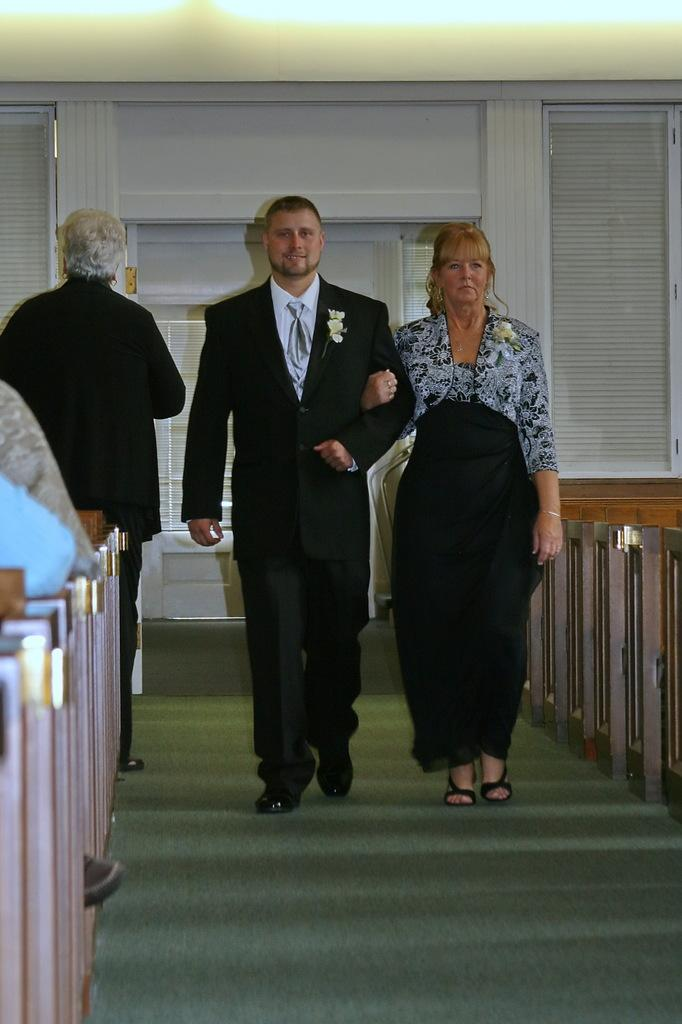Who can be seen in the image? There is a couple in the image. What are they doing in the image? The couple is walking on a green carpet. Can you describe the attire of the person on the left? The person on the left is wearing a black suit. Are there any other people visible in the image? Yes, there are other people on the left side of the image. What is the color of the background in the image? The background in the image is white. What type of prose is being recited by the couple in the image? There is no indication in the image that the couple is reciting any prose or engaging in any literary activity. 